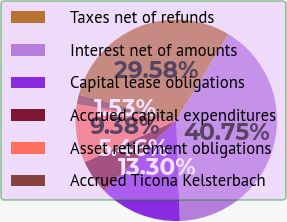<chart> <loc_0><loc_0><loc_500><loc_500><pie_chart><fcel>Taxes net of refunds<fcel>Interest net of amounts<fcel>Capital lease obligations<fcel>Accrued capital expenditures<fcel>Asset retirement obligations<fcel>Accrued Ticona Kelsterbach<nl><fcel>29.58%<fcel>40.75%<fcel>13.3%<fcel>5.46%<fcel>9.38%<fcel>1.53%<nl></chart> 